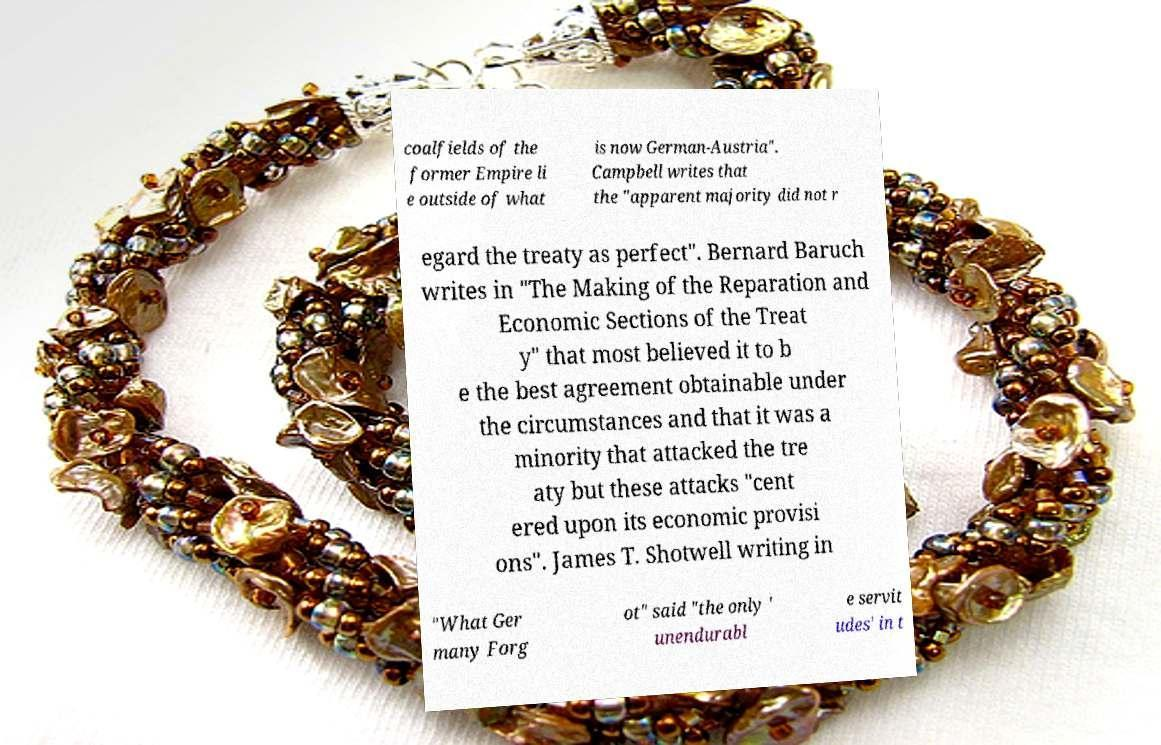Can you accurately transcribe the text from the provided image for me? coalfields of the former Empire li e outside of what is now German-Austria". Campbell writes that the "apparent majority did not r egard the treaty as perfect". Bernard Baruch writes in "The Making of the Reparation and Economic Sections of the Treat y" that most believed it to b e the best agreement obtainable under the circumstances and that it was a minority that attacked the tre aty but these attacks "cent ered upon its economic provisi ons". James T. Shotwell writing in "What Ger many Forg ot" said "the only ' unendurabl e servit udes' in t 